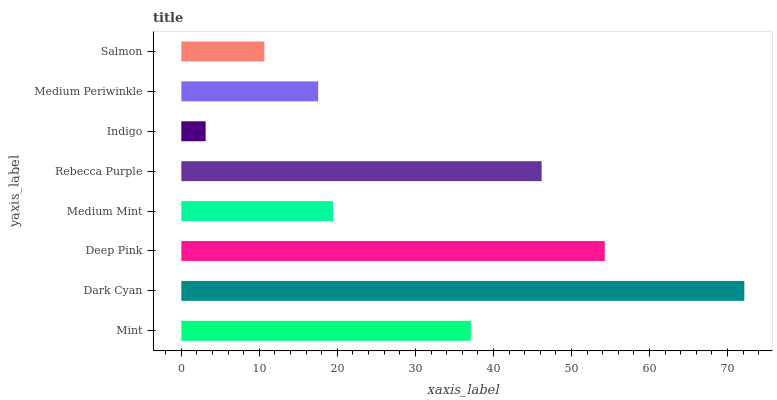Is Indigo the minimum?
Answer yes or no. Yes. Is Dark Cyan the maximum?
Answer yes or no. Yes. Is Deep Pink the minimum?
Answer yes or no. No. Is Deep Pink the maximum?
Answer yes or no. No. Is Dark Cyan greater than Deep Pink?
Answer yes or no. Yes. Is Deep Pink less than Dark Cyan?
Answer yes or no. Yes. Is Deep Pink greater than Dark Cyan?
Answer yes or no. No. Is Dark Cyan less than Deep Pink?
Answer yes or no. No. Is Mint the high median?
Answer yes or no. Yes. Is Medium Mint the low median?
Answer yes or no. Yes. Is Indigo the high median?
Answer yes or no. No. Is Salmon the low median?
Answer yes or no. No. 